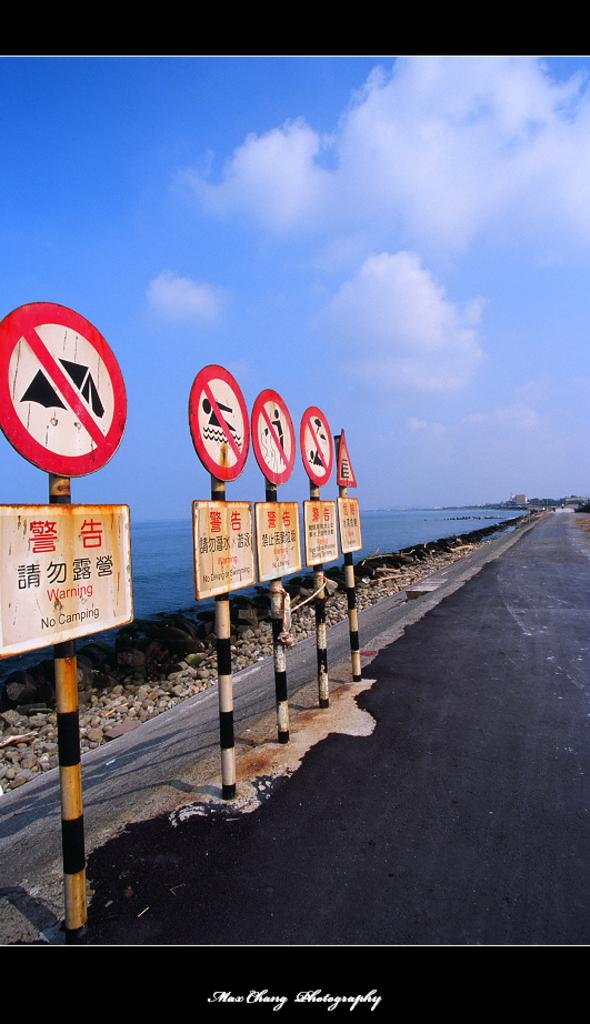<image>
Offer a succinct explanation of the picture presented. Several signs warning against camping, swimming and dumping are posted on the side of the path. 